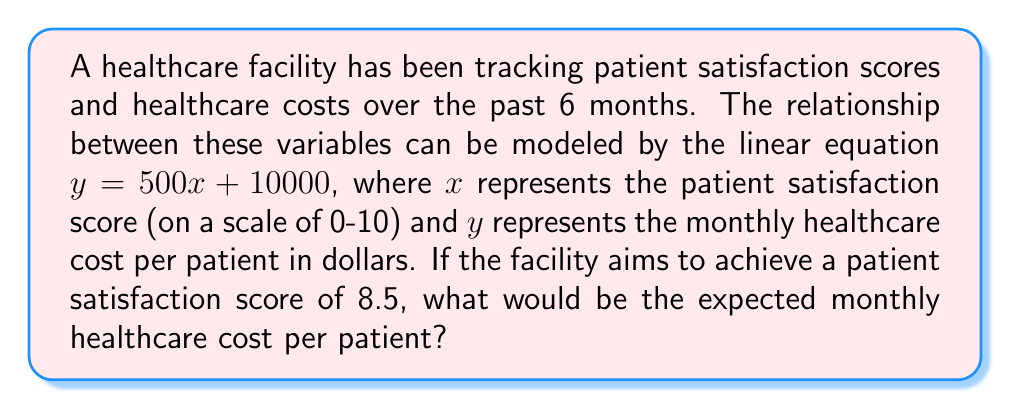What is the answer to this math problem? Let's approach this step-by-step:

1) We are given the linear equation: $y = 500x + 10000$

   Where:
   $x$ = patient satisfaction score
   $y$ = monthly healthcare cost per patient in dollars

2) We want to find $y$ when $x = 8.5$

3) Let's substitute $x = 8.5$ into the equation:

   $y = 500(8.5) + 10000$

4) First, let's multiply 500 by 8.5:
   
   $500 * 8.5 = 4250$

5) Now our equation looks like:

   $y = 4250 + 10000$

6) Finally, let's add these numbers:

   $y = 14250$

Therefore, when the patient satisfaction score is 8.5, the expected monthly healthcare cost per patient would be $14,250.
Answer: $14,250 